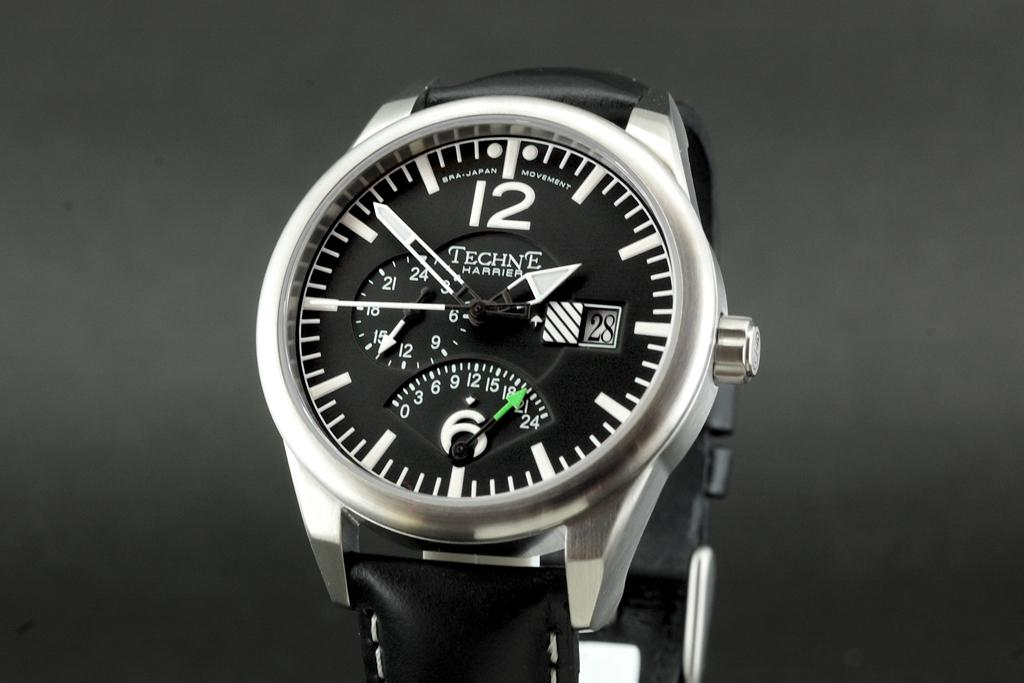<image>
Create a compact narrative representing the image presented. Techne is the company who makes the watch. 